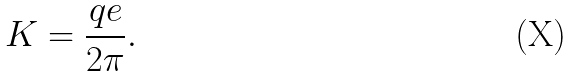<formula> <loc_0><loc_0><loc_500><loc_500>K = \frac { q e } { 2 \pi } .</formula> 